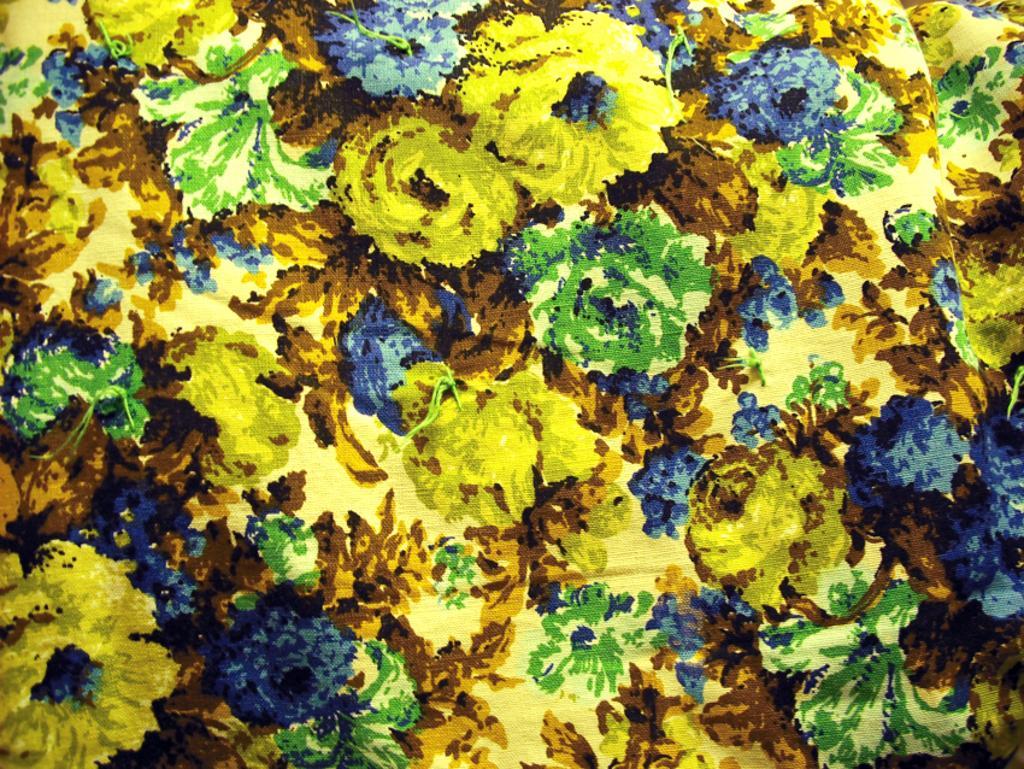Describe this image in one or two sentences. In this image I can see a painting of flowers. 